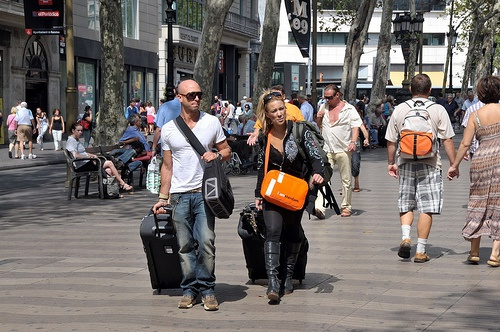Describe the objects in this image and their specific colors. I can see people in gray, lavender, black, and darkgray tones, people in gray, black, red, and orange tones, people in gray, black, and darkgray tones, people in gray, lightgray, darkgray, and black tones, and people in gray, darkgray, and tan tones in this image. 